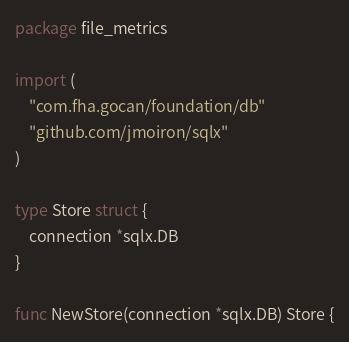<code> <loc_0><loc_0><loc_500><loc_500><_Go_>package file_metrics

import (
	"com.fha.gocan/foundation/db"
	"github.com/jmoiron/sqlx"
)

type Store struct {
	connection *sqlx.DB
}

func NewStore(connection *sqlx.DB) Store {</code> 